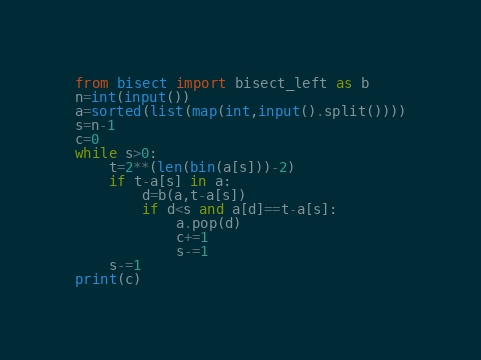<code> <loc_0><loc_0><loc_500><loc_500><_Python_>from bisect import bisect_left as b
n=int(input())
a=sorted(list(map(int,input().split())))
s=n-1
c=0
while s>0:
    t=2**(len(bin(a[s]))-2)
    if t-a[s] in a:
        d=b(a,t-a[s])
        if d<s and a[d]==t-a[s]:
            a.pop(d)
            c+=1
            s-=1
    s-=1
print(c)</code> 